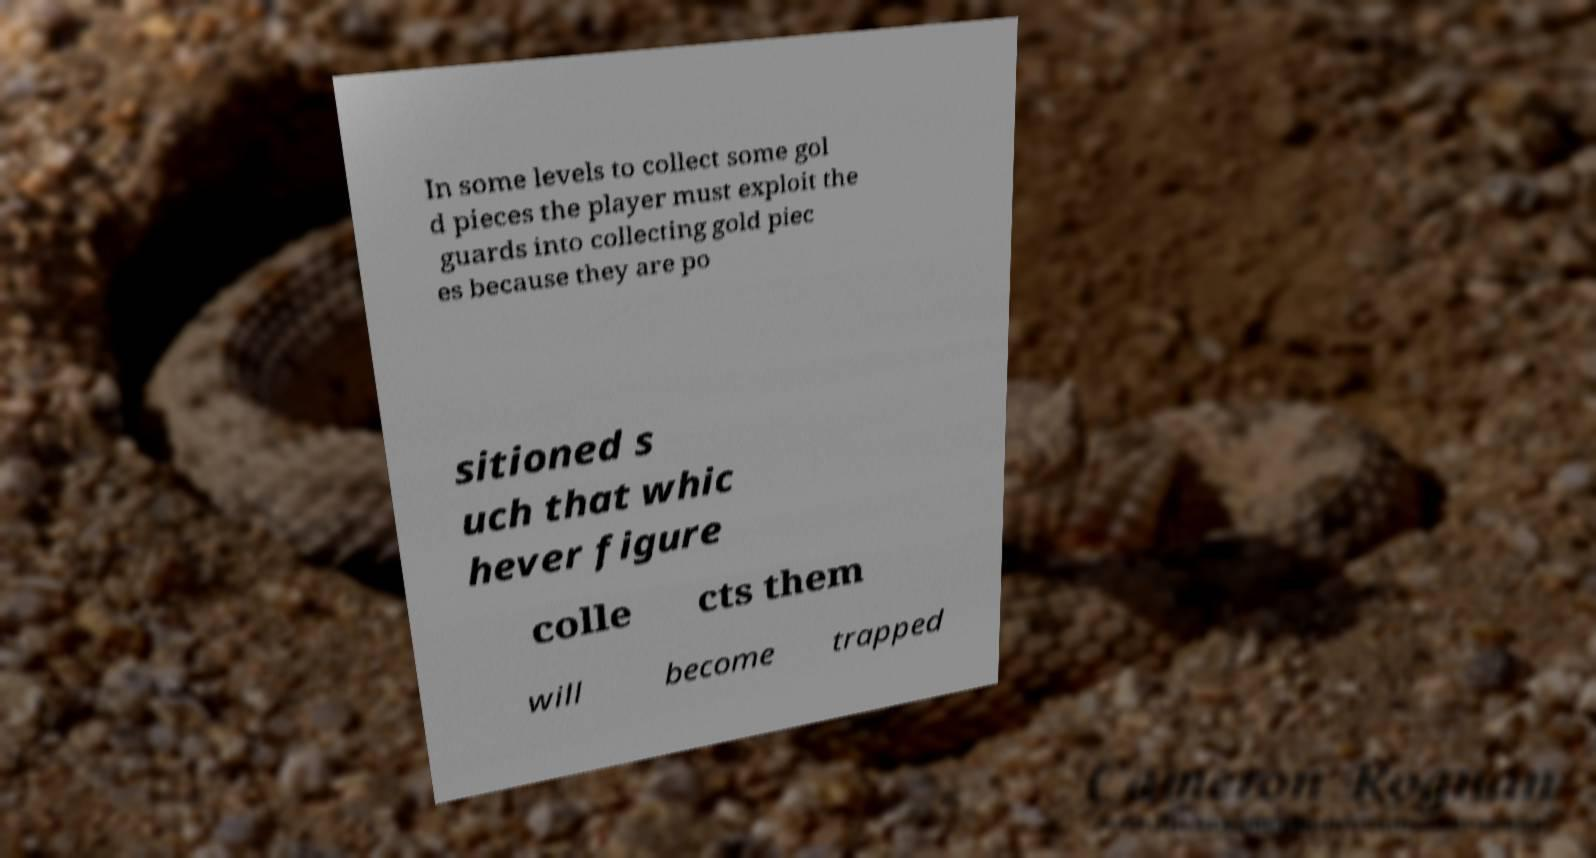For documentation purposes, I need the text within this image transcribed. Could you provide that? In some levels to collect some gol d pieces the player must exploit the guards into collecting gold piec es because they are po sitioned s uch that whic hever figure colle cts them will become trapped 